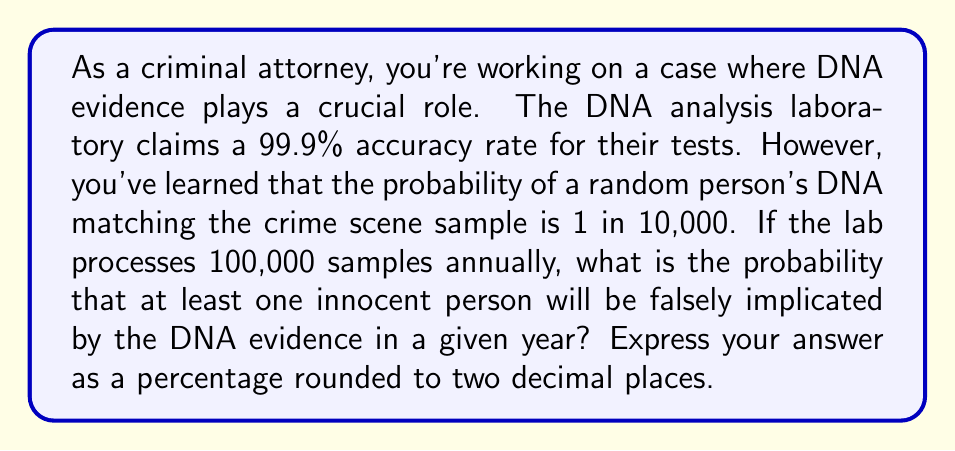Give your solution to this math problem. Let's approach this step-by-step:

1) First, we need to calculate the probability of a false positive. This occurs when:
   a) The test gives a positive result (accuracy rate), AND
   b) The person's DNA actually matches by random chance

   $P(\text{false positive}) = 0.999 \times \frac{1}{10,000} = 9.99 \times 10^{-5}$

2) The probability of not getting a false positive for one test is:

   $P(\text{not false positive}) = 1 - 9.99 \times 10^{-5} = 0.9999001$

3) For 100,000 tests, the probability of no false positives is:

   $P(\text{no false positives in 100,000 tests}) = (0.9999001)^{100,000}$

4) Therefore, the probability of at least one false positive is:

   $P(\text{at least one false positive}) = 1 - (0.9999001)^{100,000}$

5) Let's calculate this:

   $1 - (0.9999001)^{100,000} = 1 - 0.00450564 = 0.99549436$

6) Converting to a percentage:

   $0.99549436 \times 100\% = 99.55\%$

This high probability underscores the importance of considering the context and limitations of DNA evidence, even when the accuracy rate seems very high.
Answer: 99.55% 